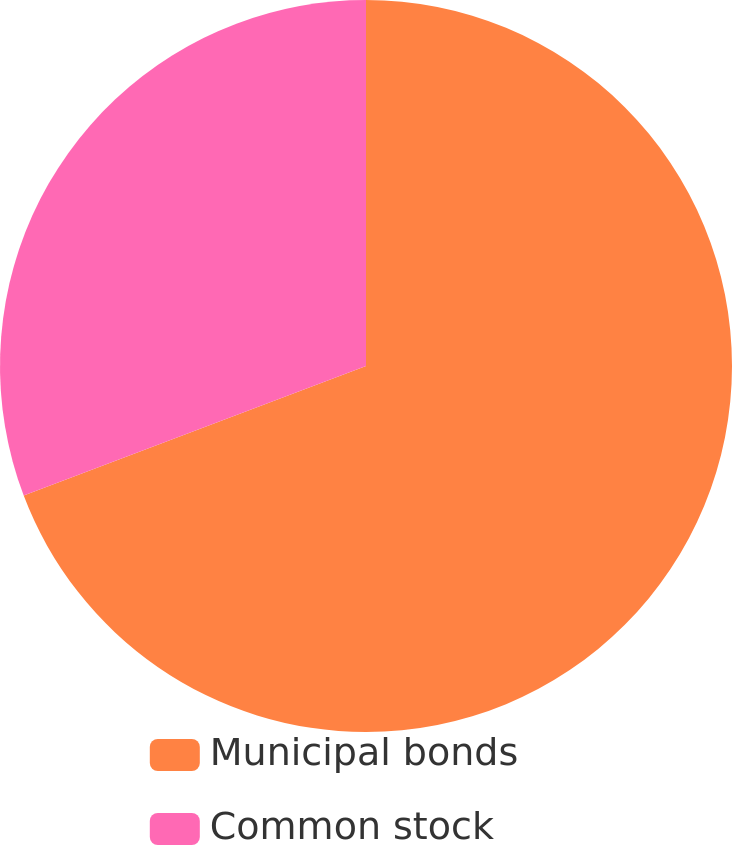Convert chart to OTSL. <chart><loc_0><loc_0><loc_500><loc_500><pie_chart><fcel>Municipal bonds<fcel>Common stock<nl><fcel>69.24%<fcel>30.76%<nl></chart> 